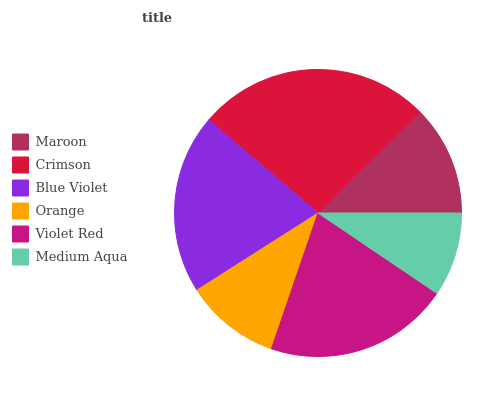Is Medium Aqua the minimum?
Answer yes or no. Yes. Is Crimson the maximum?
Answer yes or no. Yes. Is Blue Violet the minimum?
Answer yes or no. No. Is Blue Violet the maximum?
Answer yes or no. No. Is Crimson greater than Blue Violet?
Answer yes or no. Yes. Is Blue Violet less than Crimson?
Answer yes or no. Yes. Is Blue Violet greater than Crimson?
Answer yes or no. No. Is Crimson less than Blue Violet?
Answer yes or no. No. Is Blue Violet the high median?
Answer yes or no. Yes. Is Maroon the low median?
Answer yes or no. Yes. Is Violet Red the high median?
Answer yes or no. No. Is Blue Violet the low median?
Answer yes or no. No. 